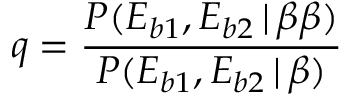Convert formula to latex. <formula><loc_0><loc_0><loc_500><loc_500>q = \frac { P ( E _ { b 1 } , E _ { b 2 } \, | \, \beta \beta ) } { P ( E _ { b 1 } , E _ { b 2 } \, | \, \beta ) }</formula> 